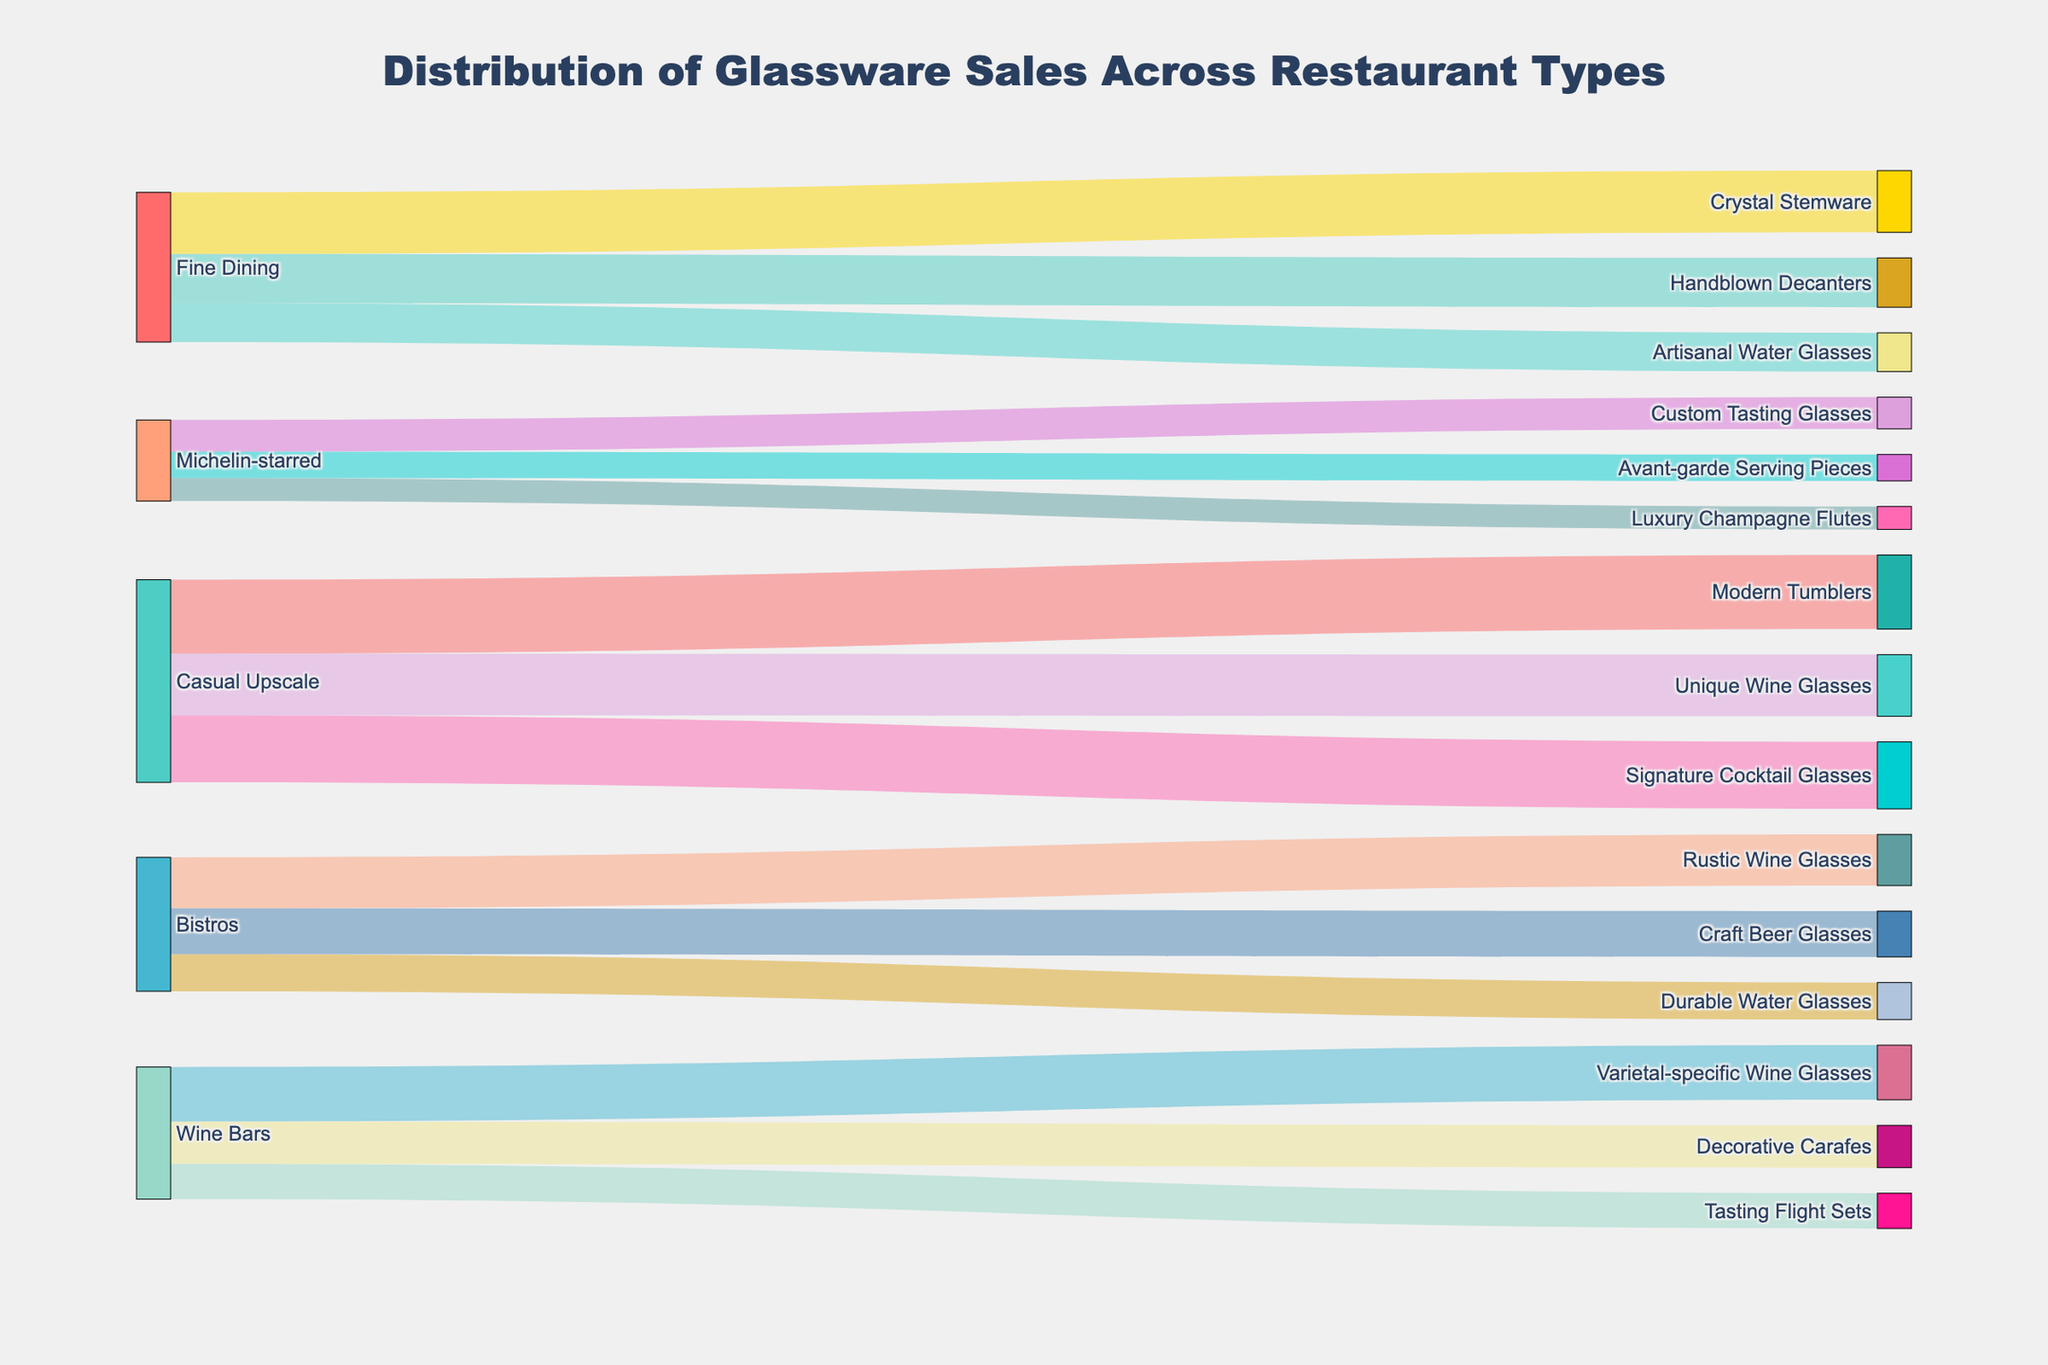Which restaurant type has the most sales in Crystal Stemware? The source and target indicate that Fine Dining is the restaurant type associated with Crystal Stemware. The value associated with this link is 3500.
Answer: Fine Dining Which glassware type associated with Bistros has the highest sales? Bistros are connected to Rustic Wine Glasses, Craft Beer Glasses, and Durable Water Glasses. Among these, Rustic Wine Glasses have a value of 2900, which is the highest.
Answer: Rustic Wine Glasses What is the total sales value for all wine glass types? Add the values for all wine glass related targets: Unique Wine Glasses (3500), Rustic Wine Glasses (2900), Luxury Champagne Flutes (1300), and Varietal-specific Wine Glasses (3100). 3500 + 2900 + 1300 + 3100 = 10800.
Answer: 10800 Which restaurant type has the least sales in glassware? Look for the restaurant type with the smallest values sum. Michelin-starred has 1800 + 1500 + 1300 = 4600. This is the smallest sum compared to other restaurant types.
Answer: Michelin-starred Compare the sales values of Custom Tasting Glasses and Avant-garde Serving Pieces for Michelin-starred restaurants. Which one is higher? Custom Tasting Glasses have a value of 1800 and Avant-garde Serving Pieces have a value of 1500. 1800 is greater than 1500.
Answer: Custom Tasting Glasses How many different glassware types are there in total? Count all unique target entries: Crystal Stemware, Handblown Decanters, Artisanal Water Glasses, Modern Tumblers, Signature Cocktail Glasses, Unique Wine Glasses, Rustic Wine Glasses, Craft Beer Glasses, Durable Water Glasses, Custom Tasting Glasses, Avant-garde Serving Pieces, Luxury Champagne Flutes, Varietal-specific Wine Glasses, Decorative Carafes, Tasting Flight Sets. This yields 15 different glassware types.
Answer: 15 What is the combined sales value for Artisanal Water Glasses? Artisanal Water Glasses are only sold in Fine Dining with a value of 2200. Thus, the total sales value is 2200.
Answer: 2200 Calculate the average sales value across all targets for Wine Bars. Find targets and their values: Varietal-specific Wine Glasses (3100), Decorative Carafes (2400), Tasting Flight Sets (2000). The sum is 3100 + 2400 + 2000 = 7500. There are 3 target types so the average is 7500 / 3 = 2500.
Answer: 2500 What are the top two glassware types in terms of sales value? Identify the top two values: Modern Tumblers (4200) and Signature Cocktail Glasses (3800) have the highest values.
Answer: Modern Tumblers and Signature Cocktail Glasses 